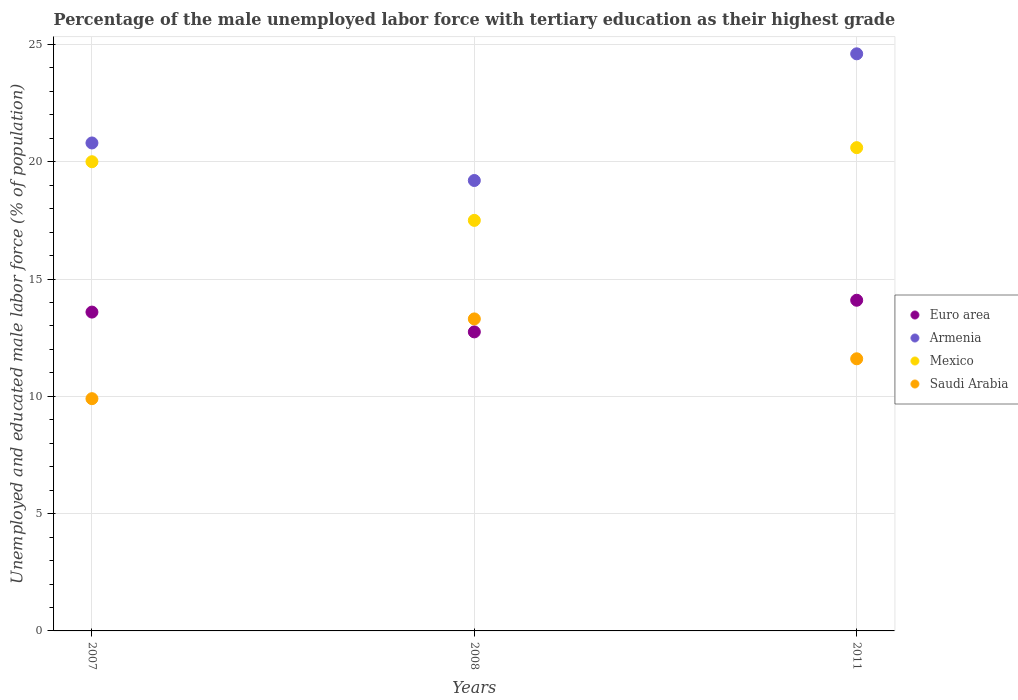How many different coloured dotlines are there?
Your response must be concise. 4. What is the percentage of the unemployed male labor force with tertiary education in Mexico in 2007?
Your answer should be very brief. 20. Across all years, what is the maximum percentage of the unemployed male labor force with tertiary education in Euro area?
Ensure brevity in your answer.  14.1. Across all years, what is the minimum percentage of the unemployed male labor force with tertiary education in Saudi Arabia?
Offer a terse response. 9.9. In which year was the percentage of the unemployed male labor force with tertiary education in Euro area minimum?
Offer a very short reply. 2008. What is the total percentage of the unemployed male labor force with tertiary education in Mexico in the graph?
Your answer should be very brief. 58.1. What is the difference between the percentage of the unemployed male labor force with tertiary education in Mexico in 2008 and that in 2011?
Give a very brief answer. -3.1. What is the difference between the percentage of the unemployed male labor force with tertiary education in Armenia in 2011 and the percentage of the unemployed male labor force with tertiary education in Saudi Arabia in 2008?
Your answer should be very brief. 11.3. What is the average percentage of the unemployed male labor force with tertiary education in Mexico per year?
Your answer should be very brief. 19.37. In the year 2008, what is the difference between the percentage of the unemployed male labor force with tertiary education in Saudi Arabia and percentage of the unemployed male labor force with tertiary education in Armenia?
Make the answer very short. -5.9. What is the ratio of the percentage of the unemployed male labor force with tertiary education in Saudi Arabia in 2007 to that in 2011?
Ensure brevity in your answer.  0.85. What is the difference between the highest and the second highest percentage of the unemployed male labor force with tertiary education in Armenia?
Make the answer very short. 3.8. What is the difference between the highest and the lowest percentage of the unemployed male labor force with tertiary education in Mexico?
Ensure brevity in your answer.  3.1. Is it the case that in every year, the sum of the percentage of the unemployed male labor force with tertiary education in Euro area and percentage of the unemployed male labor force with tertiary education in Saudi Arabia  is greater than the sum of percentage of the unemployed male labor force with tertiary education in Mexico and percentage of the unemployed male labor force with tertiary education in Armenia?
Provide a succinct answer. No. Is it the case that in every year, the sum of the percentage of the unemployed male labor force with tertiary education in Armenia and percentage of the unemployed male labor force with tertiary education in Saudi Arabia  is greater than the percentage of the unemployed male labor force with tertiary education in Mexico?
Provide a short and direct response. Yes. Is the percentage of the unemployed male labor force with tertiary education in Euro area strictly less than the percentage of the unemployed male labor force with tertiary education in Mexico over the years?
Keep it short and to the point. Yes. How many dotlines are there?
Offer a very short reply. 4. What is the difference between two consecutive major ticks on the Y-axis?
Keep it short and to the point. 5. Are the values on the major ticks of Y-axis written in scientific E-notation?
Keep it short and to the point. No. Does the graph contain any zero values?
Provide a short and direct response. No. Does the graph contain grids?
Ensure brevity in your answer.  Yes. How are the legend labels stacked?
Make the answer very short. Vertical. What is the title of the graph?
Offer a very short reply. Percentage of the male unemployed labor force with tertiary education as their highest grade. What is the label or title of the Y-axis?
Keep it short and to the point. Unemployed and educated male labor force (% of population). What is the Unemployed and educated male labor force (% of population) of Euro area in 2007?
Your answer should be very brief. 13.59. What is the Unemployed and educated male labor force (% of population) of Armenia in 2007?
Make the answer very short. 20.8. What is the Unemployed and educated male labor force (% of population) of Mexico in 2007?
Provide a succinct answer. 20. What is the Unemployed and educated male labor force (% of population) in Saudi Arabia in 2007?
Make the answer very short. 9.9. What is the Unemployed and educated male labor force (% of population) in Euro area in 2008?
Provide a short and direct response. 12.75. What is the Unemployed and educated male labor force (% of population) in Armenia in 2008?
Ensure brevity in your answer.  19.2. What is the Unemployed and educated male labor force (% of population) of Mexico in 2008?
Your response must be concise. 17.5. What is the Unemployed and educated male labor force (% of population) of Saudi Arabia in 2008?
Ensure brevity in your answer.  13.3. What is the Unemployed and educated male labor force (% of population) in Euro area in 2011?
Give a very brief answer. 14.1. What is the Unemployed and educated male labor force (% of population) of Armenia in 2011?
Keep it short and to the point. 24.6. What is the Unemployed and educated male labor force (% of population) in Mexico in 2011?
Your answer should be very brief. 20.6. What is the Unemployed and educated male labor force (% of population) in Saudi Arabia in 2011?
Make the answer very short. 11.6. Across all years, what is the maximum Unemployed and educated male labor force (% of population) of Euro area?
Make the answer very short. 14.1. Across all years, what is the maximum Unemployed and educated male labor force (% of population) in Armenia?
Give a very brief answer. 24.6. Across all years, what is the maximum Unemployed and educated male labor force (% of population) of Mexico?
Offer a very short reply. 20.6. Across all years, what is the maximum Unemployed and educated male labor force (% of population) of Saudi Arabia?
Your response must be concise. 13.3. Across all years, what is the minimum Unemployed and educated male labor force (% of population) in Euro area?
Your answer should be compact. 12.75. Across all years, what is the minimum Unemployed and educated male labor force (% of population) in Armenia?
Provide a succinct answer. 19.2. Across all years, what is the minimum Unemployed and educated male labor force (% of population) of Saudi Arabia?
Offer a very short reply. 9.9. What is the total Unemployed and educated male labor force (% of population) of Euro area in the graph?
Your response must be concise. 40.43. What is the total Unemployed and educated male labor force (% of population) of Armenia in the graph?
Provide a succinct answer. 64.6. What is the total Unemployed and educated male labor force (% of population) of Mexico in the graph?
Offer a terse response. 58.1. What is the total Unemployed and educated male labor force (% of population) of Saudi Arabia in the graph?
Give a very brief answer. 34.8. What is the difference between the Unemployed and educated male labor force (% of population) of Euro area in 2007 and that in 2008?
Your answer should be compact. 0.84. What is the difference between the Unemployed and educated male labor force (% of population) of Mexico in 2007 and that in 2008?
Provide a succinct answer. 2.5. What is the difference between the Unemployed and educated male labor force (% of population) of Saudi Arabia in 2007 and that in 2008?
Your response must be concise. -3.4. What is the difference between the Unemployed and educated male labor force (% of population) in Euro area in 2007 and that in 2011?
Your answer should be very brief. -0.5. What is the difference between the Unemployed and educated male labor force (% of population) of Armenia in 2007 and that in 2011?
Your answer should be compact. -3.8. What is the difference between the Unemployed and educated male labor force (% of population) of Mexico in 2007 and that in 2011?
Offer a very short reply. -0.6. What is the difference between the Unemployed and educated male labor force (% of population) of Euro area in 2008 and that in 2011?
Your response must be concise. -1.35. What is the difference between the Unemployed and educated male labor force (% of population) in Euro area in 2007 and the Unemployed and educated male labor force (% of population) in Armenia in 2008?
Provide a succinct answer. -5.61. What is the difference between the Unemployed and educated male labor force (% of population) of Euro area in 2007 and the Unemployed and educated male labor force (% of population) of Mexico in 2008?
Offer a very short reply. -3.91. What is the difference between the Unemployed and educated male labor force (% of population) of Euro area in 2007 and the Unemployed and educated male labor force (% of population) of Saudi Arabia in 2008?
Offer a terse response. 0.29. What is the difference between the Unemployed and educated male labor force (% of population) in Armenia in 2007 and the Unemployed and educated male labor force (% of population) in Mexico in 2008?
Your answer should be very brief. 3.3. What is the difference between the Unemployed and educated male labor force (% of population) in Armenia in 2007 and the Unemployed and educated male labor force (% of population) in Saudi Arabia in 2008?
Make the answer very short. 7.5. What is the difference between the Unemployed and educated male labor force (% of population) of Mexico in 2007 and the Unemployed and educated male labor force (% of population) of Saudi Arabia in 2008?
Your answer should be very brief. 6.7. What is the difference between the Unemployed and educated male labor force (% of population) in Euro area in 2007 and the Unemployed and educated male labor force (% of population) in Armenia in 2011?
Your answer should be very brief. -11.01. What is the difference between the Unemployed and educated male labor force (% of population) in Euro area in 2007 and the Unemployed and educated male labor force (% of population) in Mexico in 2011?
Provide a succinct answer. -7.01. What is the difference between the Unemployed and educated male labor force (% of population) in Euro area in 2007 and the Unemployed and educated male labor force (% of population) in Saudi Arabia in 2011?
Provide a short and direct response. 1.99. What is the difference between the Unemployed and educated male labor force (% of population) in Armenia in 2007 and the Unemployed and educated male labor force (% of population) in Saudi Arabia in 2011?
Provide a succinct answer. 9.2. What is the difference between the Unemployed and educated male labor force (% of population) of Euro area in 2008 and the Unemployed and educated male labor force (% of population) of Armenia in 2011?
Your response must be concise. -11.85. What is the difference between the Unemployed and educated male labor force (% of population) of Euro area in 2008 and the Unemployed and educated male labor force (% of population) of Mexico in 2011?
Keep it short and to the point. -7.85. What is the difference between the Unemployed and educated male labor force (% of population) of Euro area in 2008 and the Unemployed and educated male labor force (% of population) of Saudi Arabia in 2011?
Ensure brevity in your answer.  1.15. What is the average Unemployed and educated male labor force (% of population) of Euro area per year?
Provide a succinct answer. 13.48. What is the average Unemployed and educated male labor force (% of population) in Armenia per year?
Provide a short and direct response. 21.53. What is the average Unemployed and educated male labor force (% of population) in Mexico per year?
Offer a terse response. 19.37. In the year 2007, what is the difference between the Unemployed and educated male labor force (% of population) of Euro area and Unemployed and educated male labor force (% of population) of Armenia?
Your answer should be compact. -7.21. In the year 2007, what is the difference between the Unemployed and educated male labor force (% of population) in Euro area and Unemployed and educated male labor force (% of population) in Mexico?
Ensure brevity in your answer.  -6.41. In the year 2007, what is the difference between the Unemployed and educated male labor force (% of population) of Euro area and Unemployed and educated male labor force (% of population) of Saudi Arabia?
Provide a short and direct response. 3.69. In the year 2007, what is the difference between the Unemployed and educated male labor force (% of population) of Armenia and Unemployed and educated male labor force (% of population) of Mexico?
Give a very brief answer. 0.8. In the year 2007, what is the difference between the Unemployed and educated male labor force (% of population) in Armenia and Unemployed and educated male labor force (% of population) in Saudi Arabia?
Provide a short and direct response. 10.9. In the year 2008, what is the difference between the Unemployed and educated male labor force (% of population) in Euro area and Unemployed and educated male labor force (% of population) in Armenia?
Your answer should be compact. -6.45. In the year 2008, what is the difference between the Unemployed and educated male labor force (% of population) of Euro area and Unemployed and educated male labor force (% of population) of Mexico?
Your answer should be compact. -4.75. In the year 2008, what is the difference between the Unemployed and educated male labor force (% of population) of Euro area and Unemployed and educated male labor force (% of population) of Saudi Arabia?
Your answer should be compact. -0.55. In the year 2008, what is the difference between the Unemployed and educated male labor force (% of population) of Armenia and Unemployed and educated male labor force (% of population) of Mexico?
Ensure brevity in your answer.  1.7. In the year 2011, what is the difference between the Unemployed and educated male labor force (% of population) in Euro area and Unemployed and educated male labor force (% of population) in Armenia?
Offer a terse response. -10.5. In the year 2011, what is the difference between the Unemployed and educated male labor force (% of population) of Euro area and Unemployed and educated male labor force (% of population) of Mexico?
Provide a short and direct response. -6.5. In the year 2011, what is the difference between the Unemployed and educated male labor force (% of population) in Euro area and Unemployed and educated male labor force (% of population) in Saudi Arabia?
Offer a terse response. 2.5. What is the ratio of the Unemployed and educated male labor force (% of population) of Euro area in 2007 to that in 2008?
Ensure brevity in your answer.  1.07. What is the ratio of the Unemployed and educated male labor force (% of population) in Mexico in 2007 to that in 2008?
Offer a terse response. 1.14. What is the ratio of the Unemployed and educated male labor force (% of population) of Saudi Arabia in 2007 to that in 2008?
Give a very brief answer. 0.74. What is the ratio of the Unemployed and educated male labor force (% of population) of Euro area in 2007 to that in 2011?
Your answer should be very brief. 0.96. What is the ratio of the Unemployed and educated male labor force (% of population) of Armenia in 2007 to that in 2011?
Make the answer very short. 0.85. What is the ratio of the Unemployed and educated male labor force (% of population) of Mexico in 2007 to that in 2011?
Offer a very short reply. 0.97. What is the ratio of the Unemployed and educated male labor force (% of population) in Saudi Arabia in 2007 to that in 2011?
Make the answer very short. 0.85. What is the ratio of the Unemployed and educated male labor force (% of population) in Euro area in 2008 to that in 2011?
Provide a short and direct response. 0.9. What is the ratio of the Unemployed and educated male labor force (% of population) of Armenia in 2008 to that in 2011?
Offer a very short reply. 0.78. What is the ratio of the Unemployed and educated male labor force (% of population) of Mexico in 2008 to that in 2011?
Provide a succinct answer. 0.85. What is the ratio of the Unemployed and educated male labor force (% of population) in Saudi Arabia in 2008 to that in 2011?
Give a very brief answer. 1.15. What is the difference between the highest and the second highest Unemployed and educated male labor force (% of population) of Euro area?
Ensure brevity in your answer.  0.5. What is the difference between the highest and the second highest Unemployed and educated male labor force (% of population) in Armenia?
Offer a terse response. 3.8. What is the difference between the highest and the second highest Unemployed and educated male labor force (% of population) of Mexico?
Offer a terse response. 0.6. What is the difference between the highest and the lowest Unemployed and educated male labor force (% of population) in Euro area?
Your answer should be compact. 1.35. What is the difference between the highest and the lowest Unemployed and educated male labor force (% of population) of Saudi Arabia?
Your answer should be compact. 3.4. 